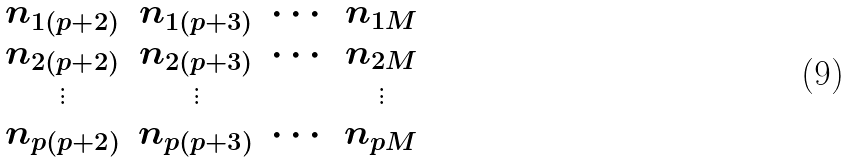Convert formula to latex. <formula><loc_0><loc_0><loc_500><loc_500>\begin{array} { c c c c } n _ { 1 ( p + 2 ) } & n _ { 1 ( p + 3 ) } & \cdots & n _ { 1 M } \\ n _ { 2 ( p + 2 ) } & n _ { 2 ( p + 3 ) } & \cdots & n _ { 2 M } \\ \vdots & \vdots & & \vdots \\ n _ { p ( p + 2 ) } & n _ { p ( p + 3 ) } & \cdots & n _ { p M } \end{array}</formula> 